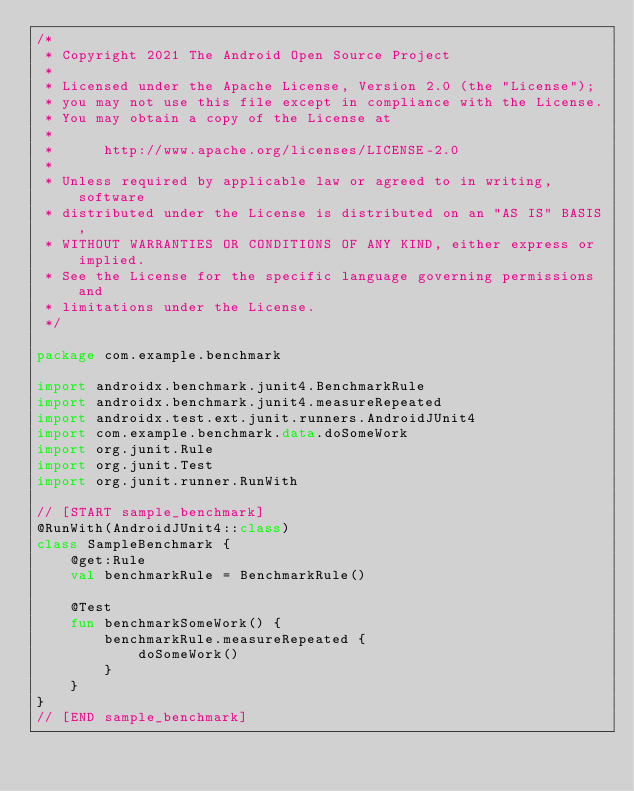<code> <loc_0><loc_0><loc_500><loc_500><_Kotlin_>/*
 * Copyright 2021 The Android Open Source Project
 *
 * Licensed under the Apache License, Version 2.0 (the "License");
 * you may not use this file except in compliance with the License.
 * You may obtain a copy of the License at
 *
 *      http://www.apache.org/licenses/LICENSE-2.0
 *
 * Unless required by applicable law or agreed to in writing, software
 * distributed under the License is distributed on an "AS IS" BASIS,
 * WITHOUT WARRANTIES OR CONDITIONS OF ANY KIND, either express or implied.
 * See the License for the specific language governing permissions and
 * limitations under the License.
 */

package com.example.benchmark

import androidx.benchmark.junit4.BenchmarkRule
import androidx.benchmark.junit4.measureRepeated
import androidx.test.ext.junit.runners.AndroidJUnit4
import com.example.benchmark.data.doSomeWork
import org.junit.Rule
import org.junit.Test
import org.junit.runner.RunWith

// [START sample_benchmark]
@RunWith(AndroidJUnit4::class)
class SampleBenchmark {
    @get:Rule
    val benchmarkRule = BenchmarkRule()

    @Test
    fun benchmarkSomeWork() {
        benchmarkRule.measureRepeated {
            doSomeWork()
        }
    }
}
// [END sample_benchmark]
</code> 